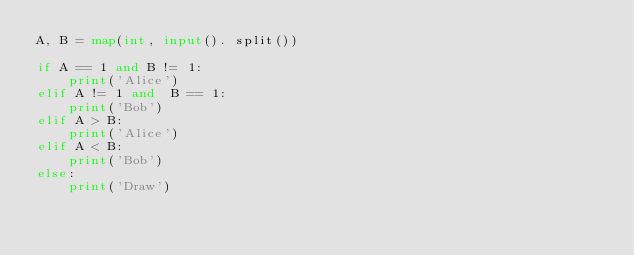Convert code to text. <code><loc_0><loc_0><loc_500><loc_500><_Python_>A, B = map(int, input(). split())

if A == 1 and B != 1:
    print('Alice')
elif A != 1 and  B == 1:
    print('Bob')
elif A > B:
    print('Alice')
elif A < B:
    print('Bob')
else:
    print('Draw')</code> 